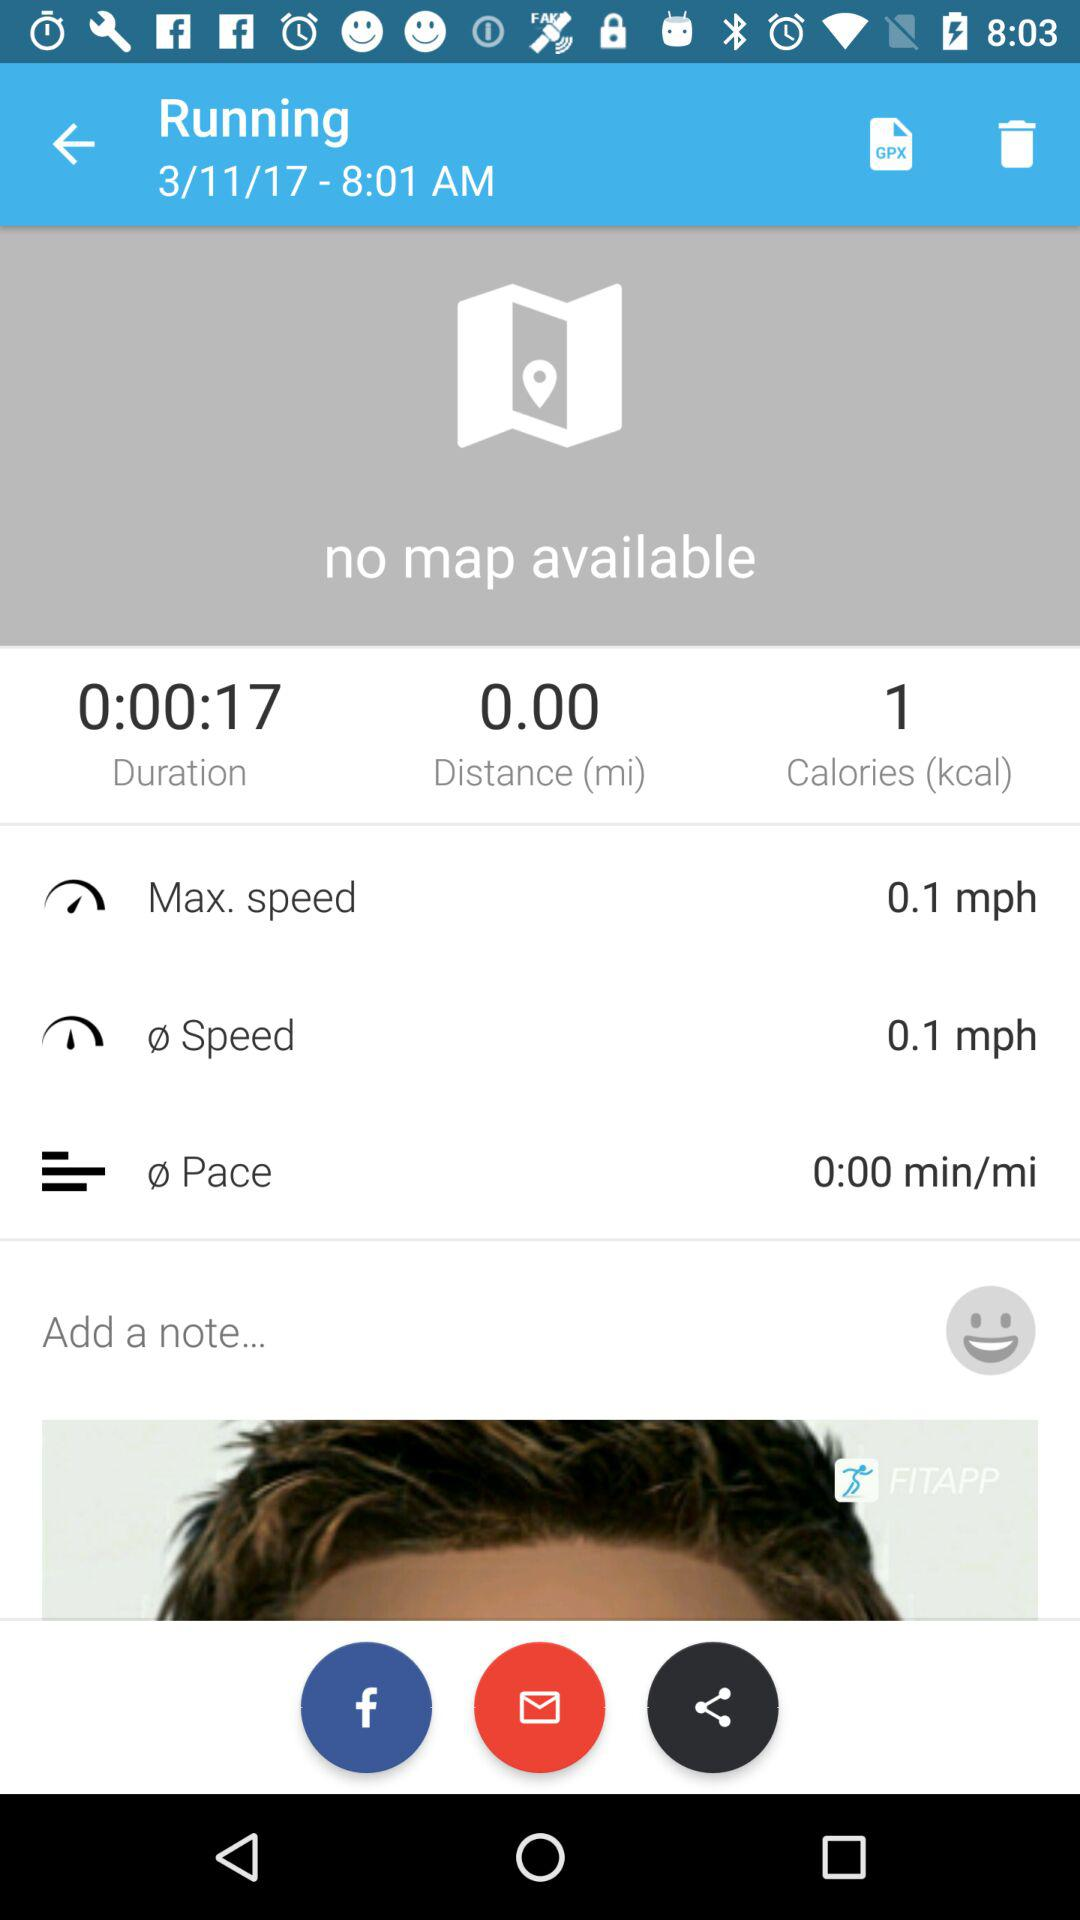What is the time duration? The time duration is 17 seconds. 